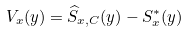Convert formula to latex. <formula><loc_0><loc_0><loc_500><loc_500>V _ { x } ( y ) = \widehat { S } _ { x , C } ( y ) - S _ { x } ^ { \ast } ( y )</formula> 